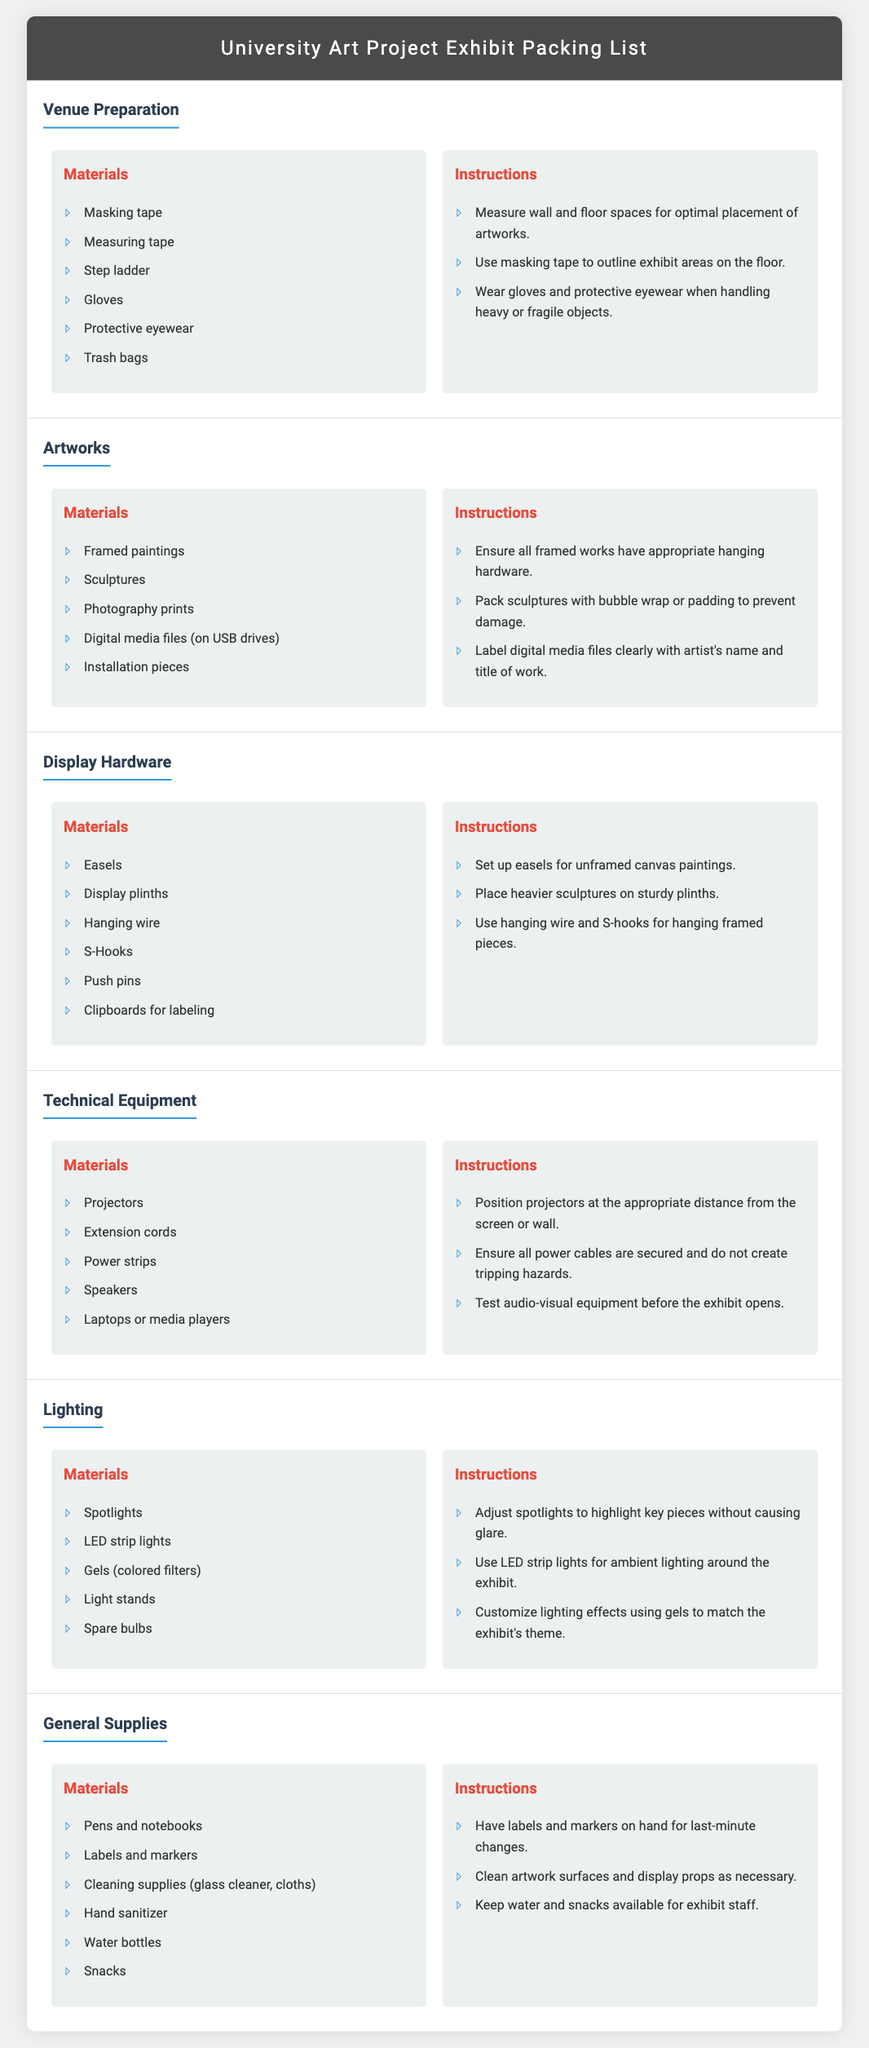What is the first item listed under Venue Preparation Materials? The first item under Venue Preparation Materials in the document is "Masking tape."
Answer: Masking tape How many types of artworks are listed in the document? The document lists five types of artworks under the Artworks section.
Answer: 5 What should you do before the exhibit opens regarding technical equipment? You should "Test audio-visual equipment before the exhibit opens." in the Technical Equipment section.
Answer: Test audio-visual equipment Which materials are needed for general supplies? The General Supplies section lists various items including "Pens and notebooks."
Answer: Pens and notebooks What is one type of lighting mentioned in the document? The document mentions "Spotlights" as one type of lighting under the Lighting section.
Answer: Spotlights How should heavier sculptures be placed? The instruction states to "Place heavier sculptures on sturdy plinths."
Answer: On sturdy plinths What is the main purpose of using gloves and protective eyewear? The document advises to "Wear gloves and protective eyewear when handling heavy or fragile objects."
Answer: Handling heavy or fragile objects What filtering materials are suggested for lighting effects? The document suggests using "Gels (colored filters)" for customizing lighting effects.
Answer: Gels (colored filters) 